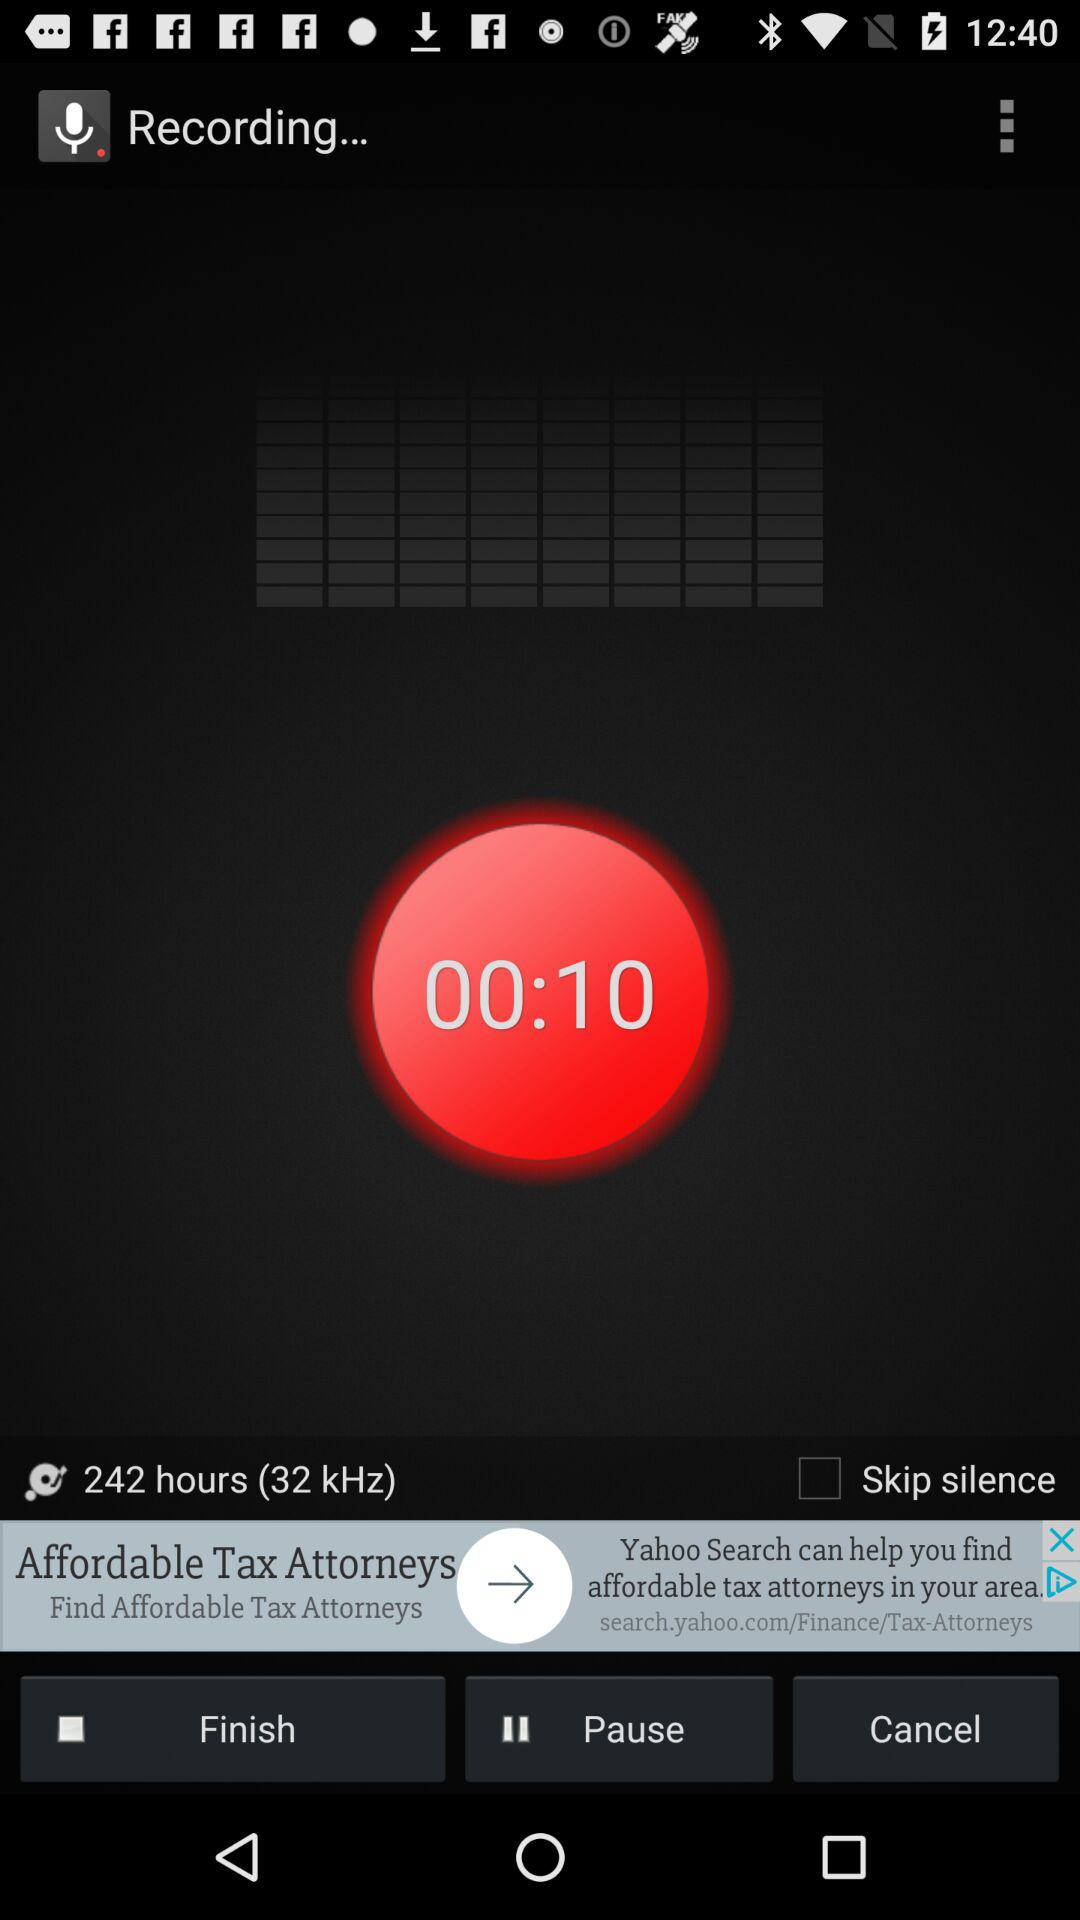What is the recording's file size?
When the provided information is insufficient, respond with <no answer>. <no answer> 